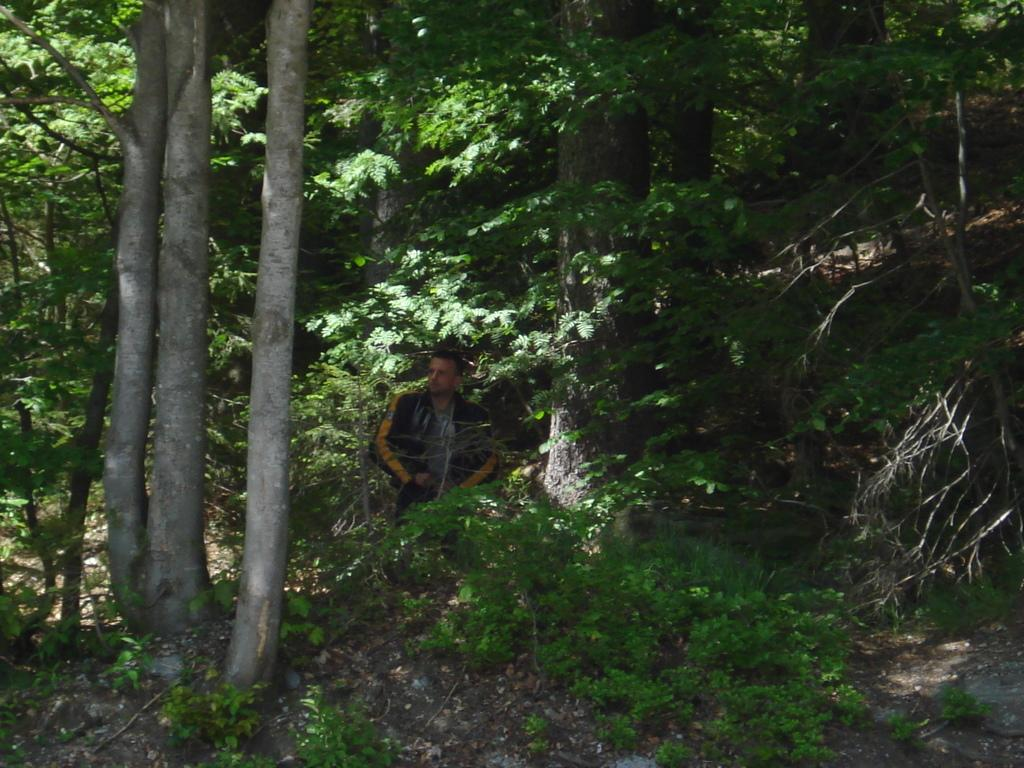What is the main subject of the image? There is a man standing in the image. What is the man's position in relation to the ground? The man is standing on the ground. What can be seen in the background of the image? There are trees in the background of the image. What type of beef is being served on a silver platter in the image? There is no beef or silver platter present in the image. How many pets are visible in the image? There are no pets visible in the image. 